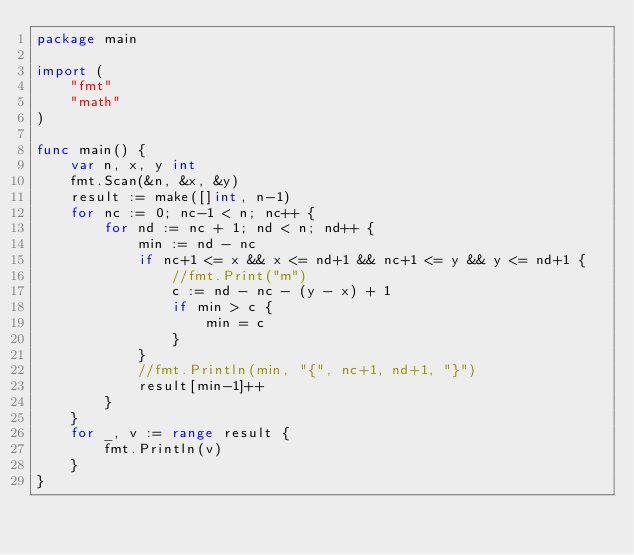<code> <loc_0><loc_0><loc_500><loc_500><_Go_>package main

import (
	"fmt"
	"math"
)

func main() {
	var n, x, y int
	fmt.Scan(&n, &x, &y)
	result := make([]int, n-1)
	for nc := 0; nc-1 < n; nc++ {
		for nd := nc + 1; nd < n; nd++ {
			min := nd - nc
			if nc+1 <= x && x <= nd+1 && nc+1 <= y && y <= nd+1 {
				//fmt.Print("m")
				c := nd - nc - (y - x) + 1
				if min > c {
					min = c
				}
			}
			//fmt.Println(min, "{", nc+1, nd+1, "}")
			result[min-1]++
		}
	}
	for _, v := range result {
		fmt.Println(v)
	}
}</code> 